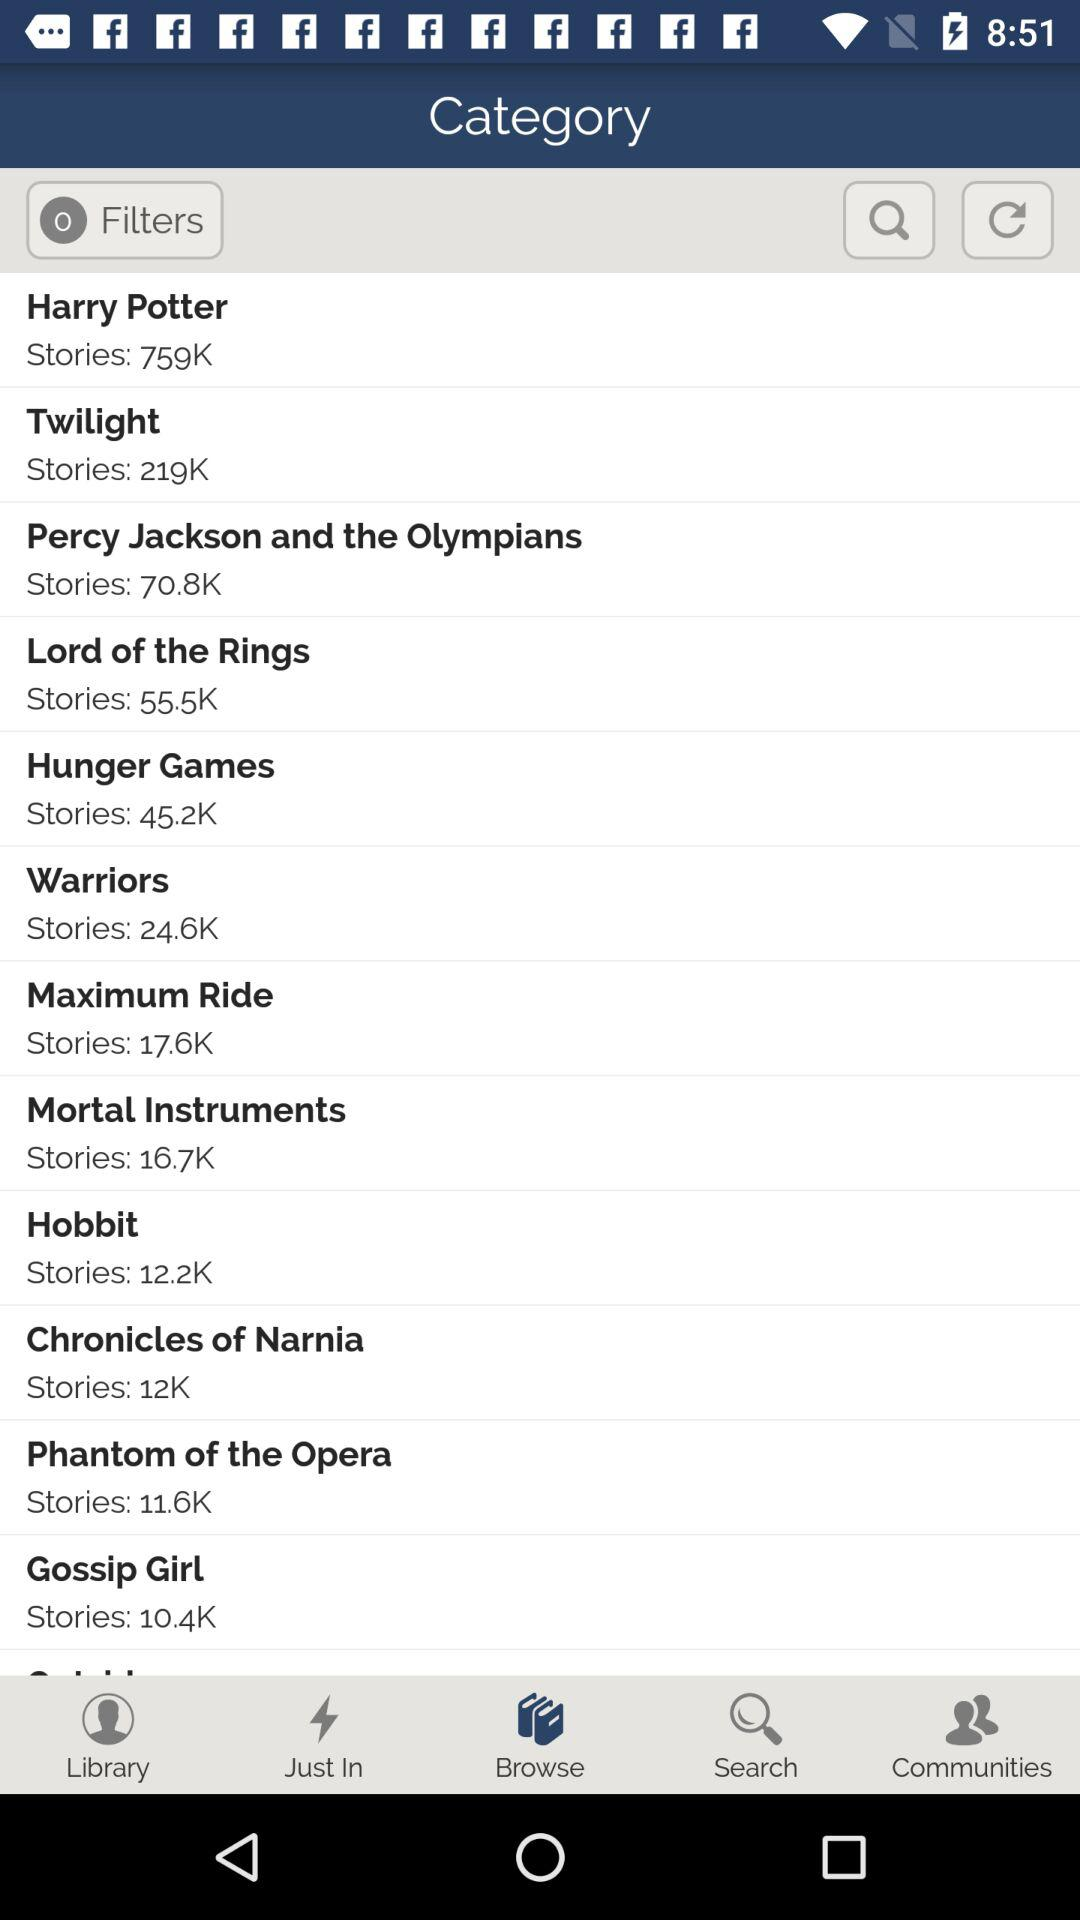What is the story count for "Harry Potter"? The story count for "Harry Potter" is 759K. 